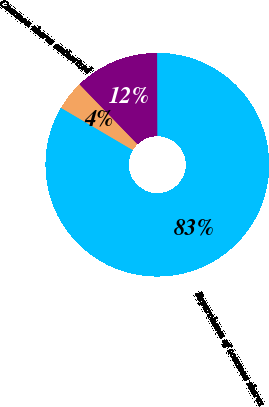Convert chart. <chart><loc_0><loc_0><loc_500><loc_500><pie_chart><fcel>Common shares authorized<fcel>Repurchases of common shares<fcel>Other primarily stock option<nl><fcel>4.29%<fcel>83.49%<fcel>12.21%<nl></chart> 